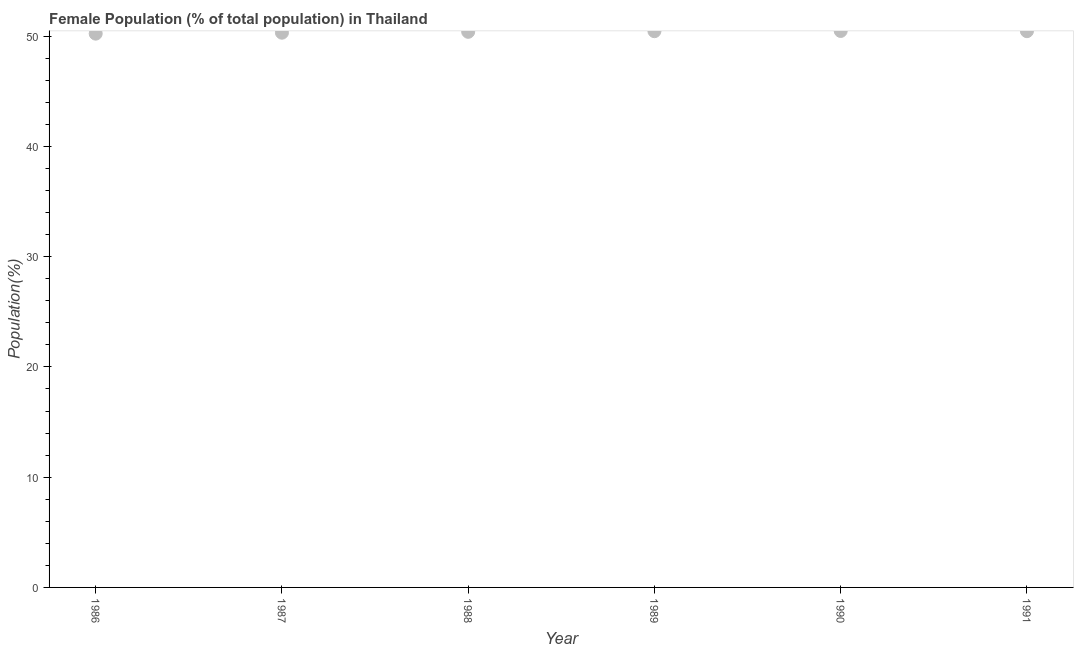What is the female population in 1986?
Make the answer very short. 50.22. Across all years, what is the maximum female population?
Your response must be concise. 50.47. Across all years, what is the minimum female population?
Your response must be concise. 50.22. In which year was the female population maximum?
Make the answer very short. 1990. In which year was the female population minimum?
Offer a very short reply. 1986. What is the sum of the female population?
Provide a short and direct response. 302.28. What is the difference between the female population in 1986 and 1990?
Provide a short and direct response. -0.24. What is the average female population per year?
Provide a succinct answer. 50.38. What is the median female population?
Your answer should be compact. 50.42. What is the ratio of the female population in 1989 to that in 1991?
Your answer should be very brief. 1. What is the difference between the highest and the second highest female population?
Your response must be concise. 0.02. Is the sum of the female population in 1986 and 1990 greater than the maximum female population across all years?
Offer a terse response. Yes. What is the difference between the highest and the lowest female population?
Offer a very short reply. 0.24. How many dotlines are there?
Offer a very short reply. 1. How many years are there in the graph?
Make the answer very short. 6. What is the difference between two consecutive major ticks on the Y-axis?
Keep it short and to the point. 10. Are the values on the major ticks of Y-axis written in scientific E-notation?
Provide a succinct answer. No. Does the graph contain any zero values?
Provide a short and direct response. No. What is the title of the graph?
Ensure brevity in your answer.  Female Population (% of total population) in Thailand. What is the label or title of the Y-axis?
Your answer should be compact. Population(%). What is the Population(%) in 1986?
Make the answer very short. 50.22. What is the Population(%) in 1987?
Your response must be concise. 50.31. What is the Population(%) in 1988?
Keep it short and to the point. 50.39. What is the Population(%) in 1989?
Your answer should be compact. 50.45. What is the Population(%) in 1990?
Your response must be concise. 50.47. What is the Population(%) in 1991?
Offer a very short reply. 50.45. What is the difference between the Population(%) in 1986 and 1987?
Your answer should be compact. -0.09. What is the difference between the Population(%) in 1986 and 1988?
Offer a very short reply. -0.17. What is the difference between the Population(%) in 1986 and 1989?
Ensure brevity in your answer.  -0.22. What is the difference between the Population(%) in 1986 and 1990?
Provide a short and direct response. -0.24. What is the difference between the Population(%) in 1986 and 1991?
Ensure brevity in your answer.  -0.22. What is the difference between the Population(%) in 1987 and 1988?
Give a very brief answer. -0.08. What is the difference between the Population(%) in 1987 and 1989?
Ensure brevity in your answer.  -0.14. What is the difference between the Population(%) in 1987 and 1990?
Your response must be concise. -0.16. What is the difference between the Population(%) in 1987 and 1991?
Give a very brief answer. -0.14. What is the difference between the Population(%) in 1988 and 1989?
Give a very brief answer. -0.06. What is the difference between the Population(%) in 1988 and 1990?
Keep it short and to the point. -0.08. What is the difference between the Population(%) in 1988 and 1991?
Offer a terse response. -0.06. What is the difference between the Population(%) in 1989 and 1990?
Offer a terse response. -0.02. What is the difference between the Population(%) in 1989 and 1991?
Provide a succinct answer. -0. What is the difference between the Population(%) in 1990 and 1991?
Offer a terse response. 0.02. What is the ratio of the Population(%) in 1986 to that in 1988?
Provide a succinct answer. 1. What is the ratio of the Population(%) in 1986 to that in 1990?
Make the answer very short. 0.99. What is the ratio of the Population(%) in 1986 to that in 1991?
Keep it short and to the point. 1. What is the ratio of the Population(%) in 1987 to that in 1988?
Make the answer very short. 1. What is the ratio of the Population(%) in 1987 to that in 1990?
Your answer should be very brief. 1. What is the ratio of the Population(%) in 1988 to that in 1990?
Your answer should be very brief. 1. What is the ratio of the Population(%) in 1988 to that in 1991?
Make the answer very short. 1. What is the ratio of the Population(%) in 1989 to that in 1990?
Keep it short and to the point. 1. What is the ratio of the Population(%) in 1989 to that in 1991?
Your answer should be compact. 1. What is the ratio of the Population(%) in 1990 to that in 1991?
Keep it short and to the point. 1. 